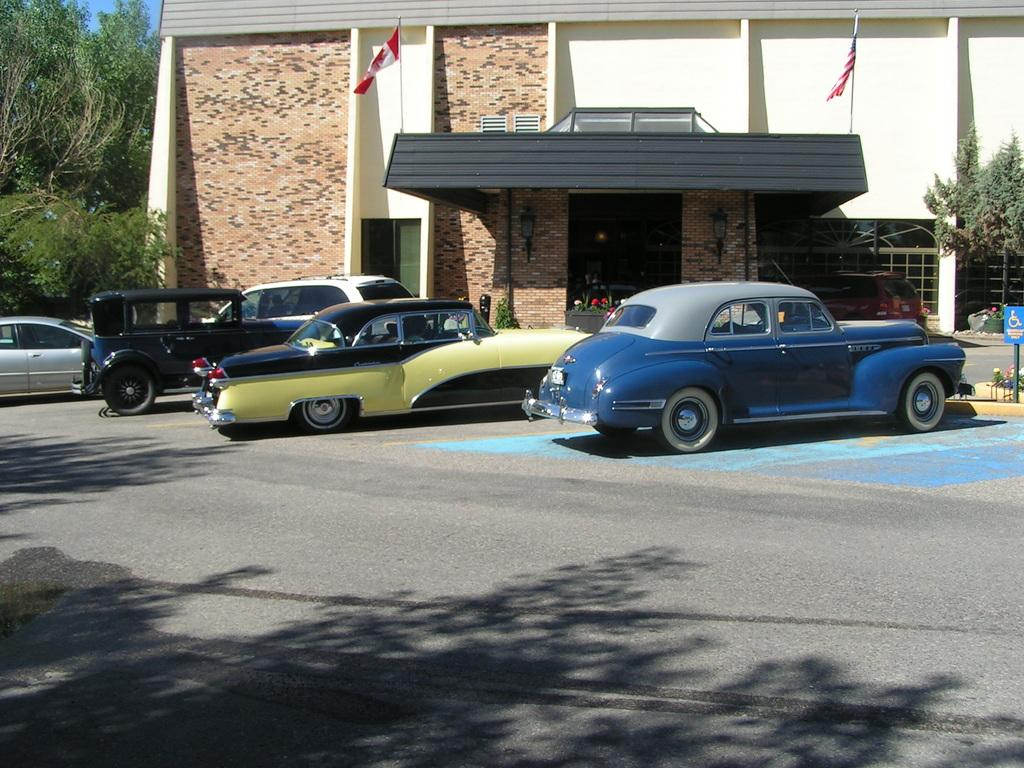What can be seen on the road in the image? There are many cars parked on the road in the image. What is visible at the bottom of the image? The road is visible at the bottom of the image. What can be seen in the background of the image? There is a building and trees in the background of the image. How many kittens are playing on the roof of the building in the image? There are no kittens present in the image; it only shows parked cars, the road, and the background with a building and trees. 